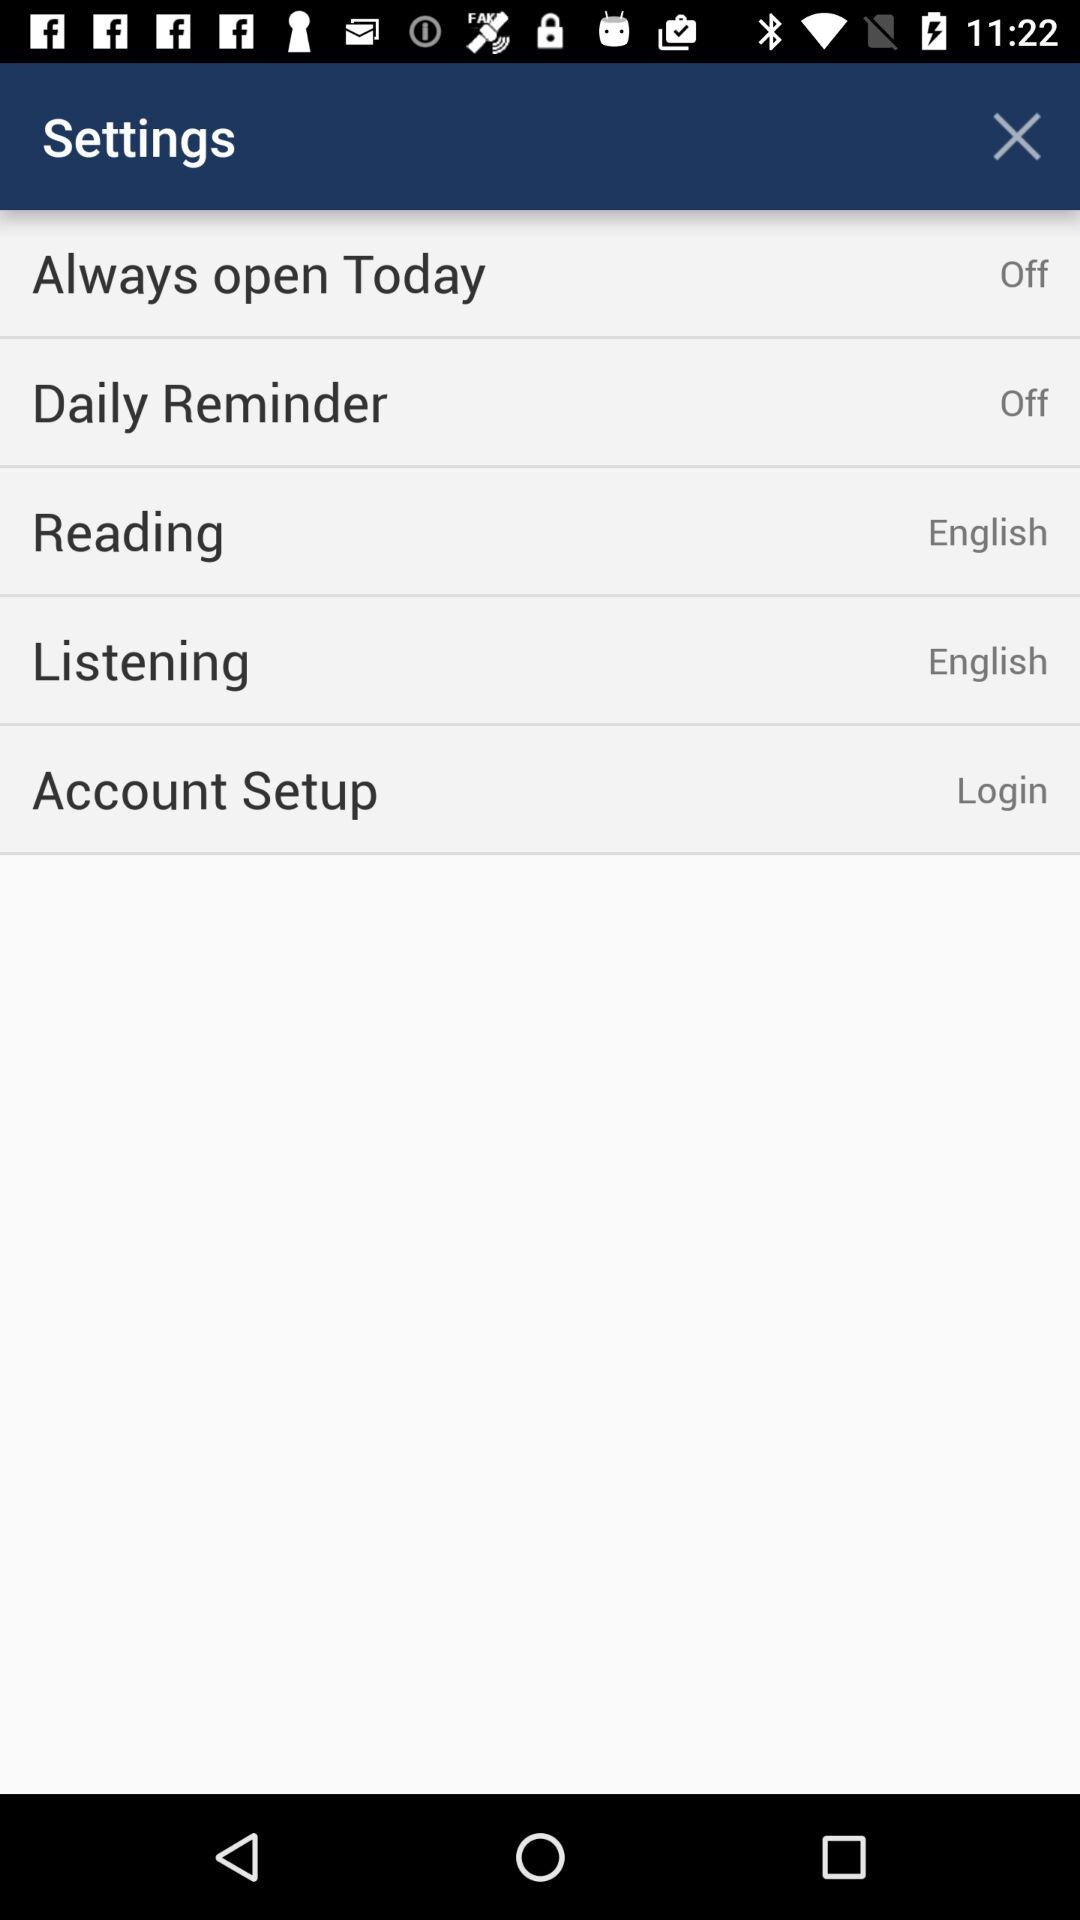How many settings are available to change?
Answer the question using a single word or phrase. 5 